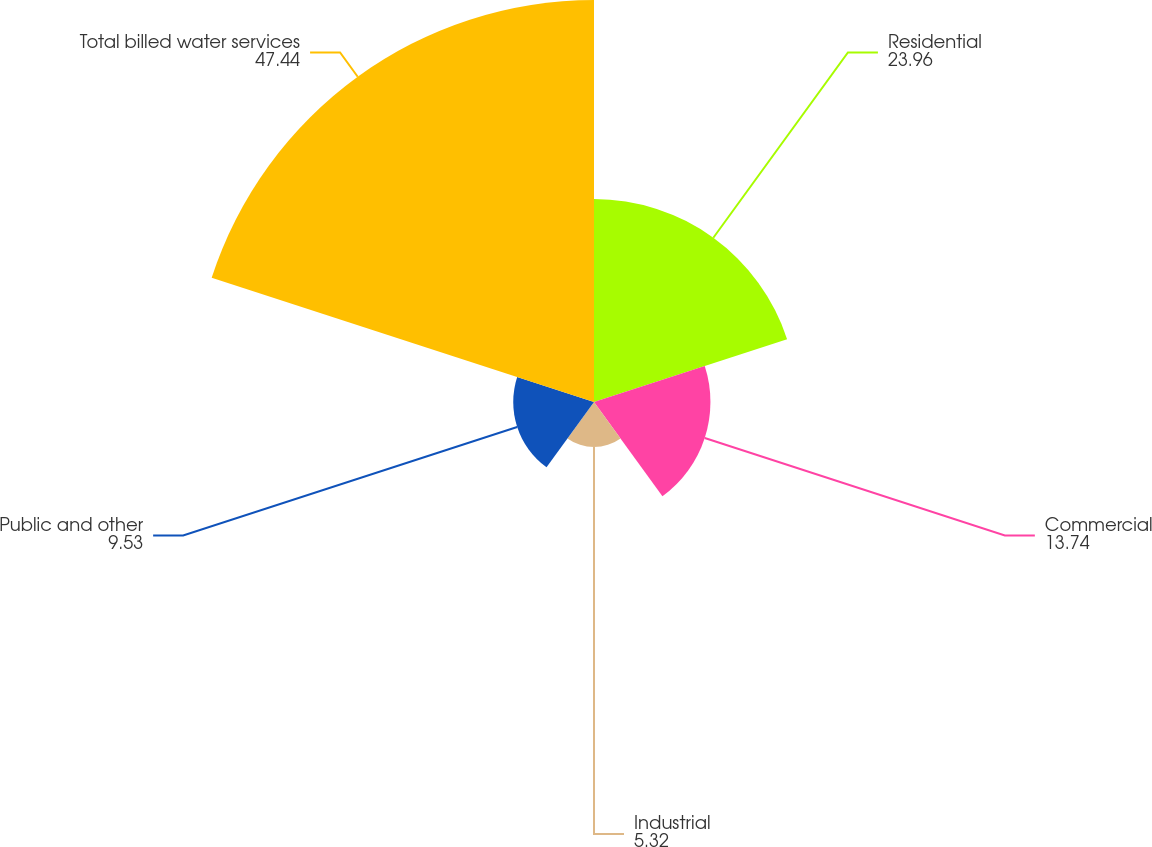Convert chart. <chart><loc_0><loc_0><loc_500><loc_500><pie_chart><fcel>Residential<fcel>Commercial<fcel>Industrial<fcel>Public and other<fcel>Total billed water services<nl><fcel>23.96%<fcel>13.74%<fcel>5.32%<fcel>9.53%<fcel>47.44%<nl></chart> 